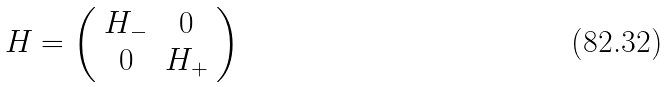Convert formula to latex. <formula><loc_0><loc_0><loc_500><loc_500>H = \left ( \begin{array} { c c } H _ { - } & 0 \\ 0 & H _ { + } \end{array} \right )</formula> 